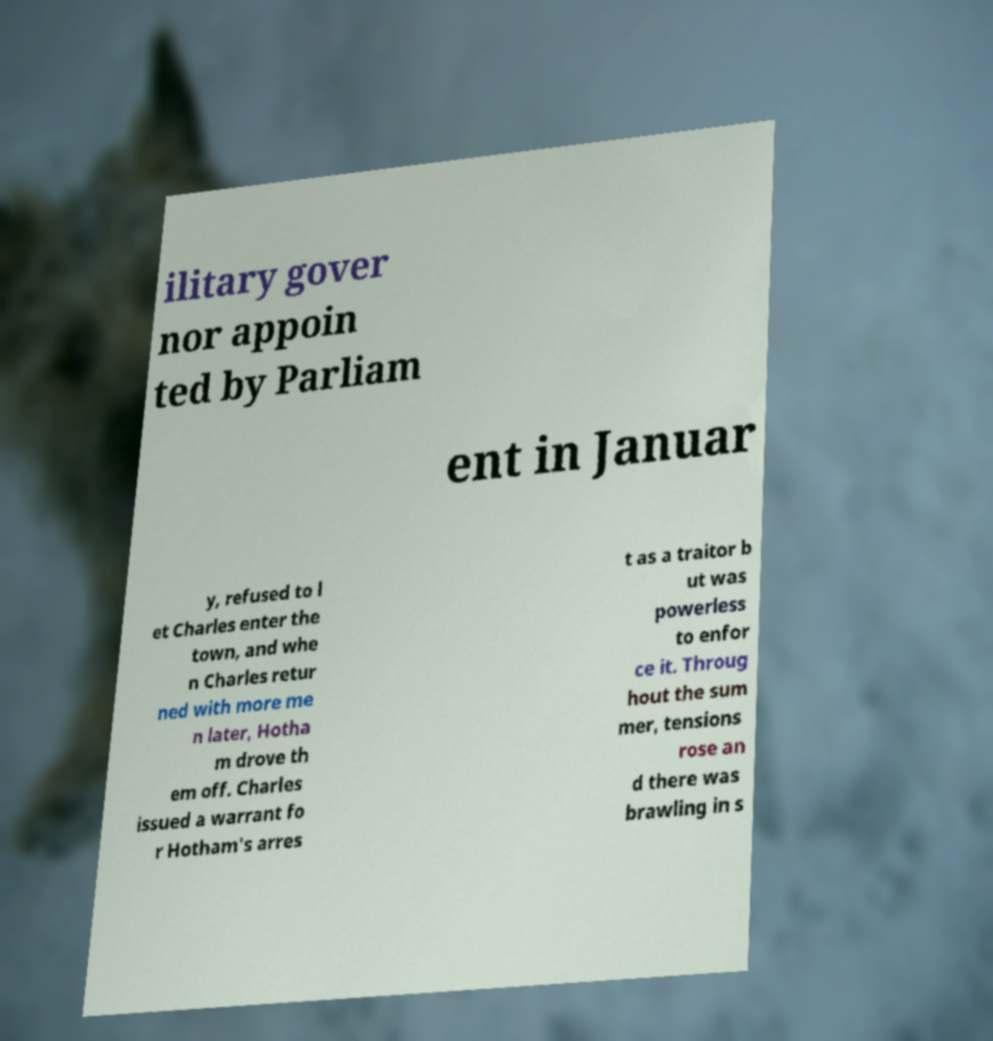Could you assist in decoding the text presented in this image and type it out clearly? ilitary gover nor appoin ted by Parliam ent in Januar y, refused to l et Charles enter the town, and whe n Charles retur ned with more me n later, Hotha m drove th em off. Charles issued a warrant fo r Hotham's arres t as a traitor b ut was powerless to enfor ce it. Throug hout the sum mer, tensions rose an d there was brawling in s 